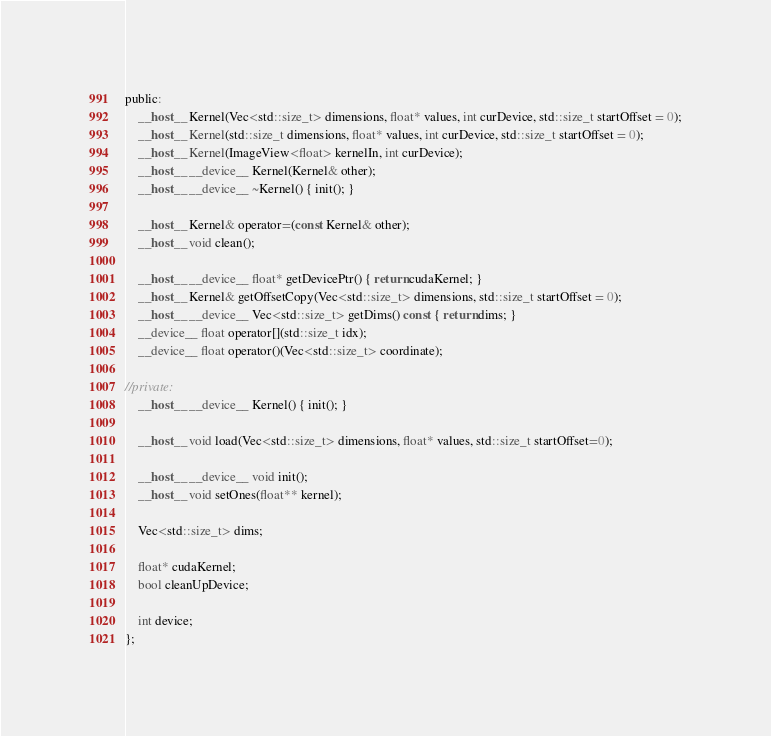Convert code to text. <code><loc_0><loc_0><loc_500><loc_500><_Cuda_>public:
	__host__ Kernel(Vec<std::size_t> dimensions, float* values, int curDevice, std::size_t startOffset = 0);
	__host__ Kernel(std::size_t dimensions, float* values, int curDevice, std::size_t startOffset = 0);
	__host__ Kernel(ImageView<float> kernelIn, int curDevice);
	__host__ __device__ Kernel(Kernel& other);
	__host__ __device__ ~Kernel() { init(); }

	__host__ Kernel& operator=(const Kernel& other);
	__host__ void clean();

	__host__ __device__ float* getDevicePtr() { return cudaKernel; }
	__host__ Kernel& getOffsetCopy(Vec<std::size_t> dimensions, std::size_t startOffset = 0);
	__host__ __device__ Vec<std::size_t> getDims() const { return dims; }
	__device__ float operator[](std::size_t idx);
	__device__ float operator()(Vec<std::size_t> coordinate);
	
//private:
	__host__ __device__ Kernel() { init(); }

	__host__ void load(Vec<std::size_t> dimensions, float* values, std::size_t startOffset=0);

	__host__ __device__ void init();
	__host__ void setOnes(float** kernel);

	Vec<std::size_t> dims;

	float* cudaKernel;
	bool cleanUpDevice;

	int device;
};
</code> 